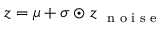<formula> <loc_0><loc_0><loc_500><loc_500>\boldsymbol z = \boldsymbol \mu + \boldsymbol \sigma \odot \boldsymbol z _ { n o i s e }</formula> 